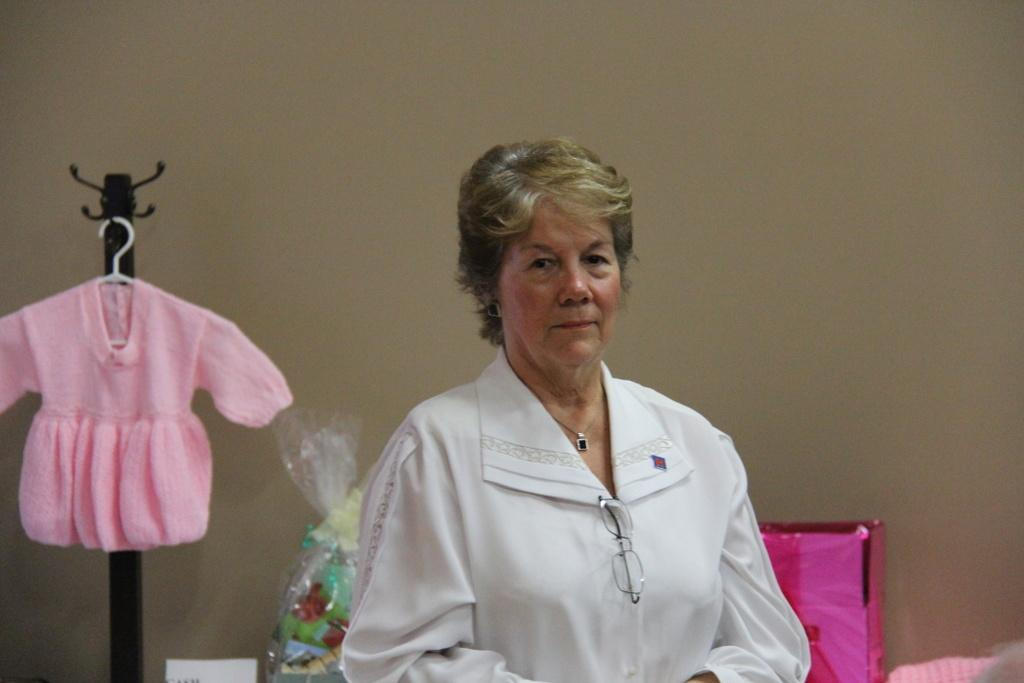Who is the main subject in the image? There is a woman in the middle of the image. What is located behind the woman? There is a gift box behind the woman. What is covering the gift box? There is a cover associated with the gift box. What type of clothing is visible behind the woman? There is a dress visible behind the woman. What is the name of the tree behind the woman in the image? There are no trees visible in the image; it only shows a woman, a gift box, its cover, and a dress. 